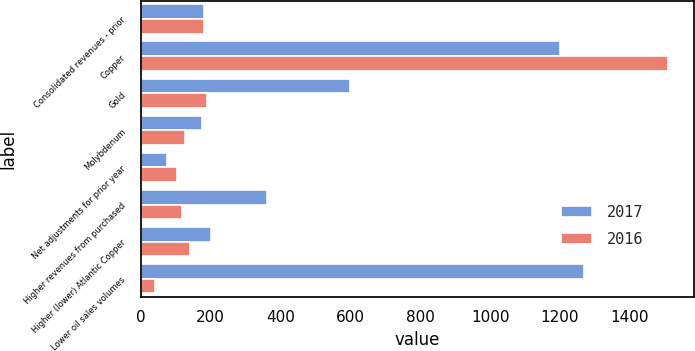Convert chart to OTSL. <chart><loc_0><loc_0><loc_500><loc_500><stacked_bar_chart><ecel><fcel>Consolidated revenues - prior<fcel>Copper<fcel>Gold<fcel>Molybdenum<fcel>Net adjustments for prior year<fcel>Higher revenues from purchased<fcel>Higher (lower) Atlantic Copper<fcel>Lower oil sales volumes<nl><fcel>2017<fcel>182.5<fcel>1201<fcel>598<fcel>175<fcel>76<fcel>361<fcel>201<fcel>1269<nl><fcel>2016<fcel>182.5<fcel>1508<fcel>190<fcel>128<fcel>105<fcel>117<fcel>140<fcel>40<nl></chart> 